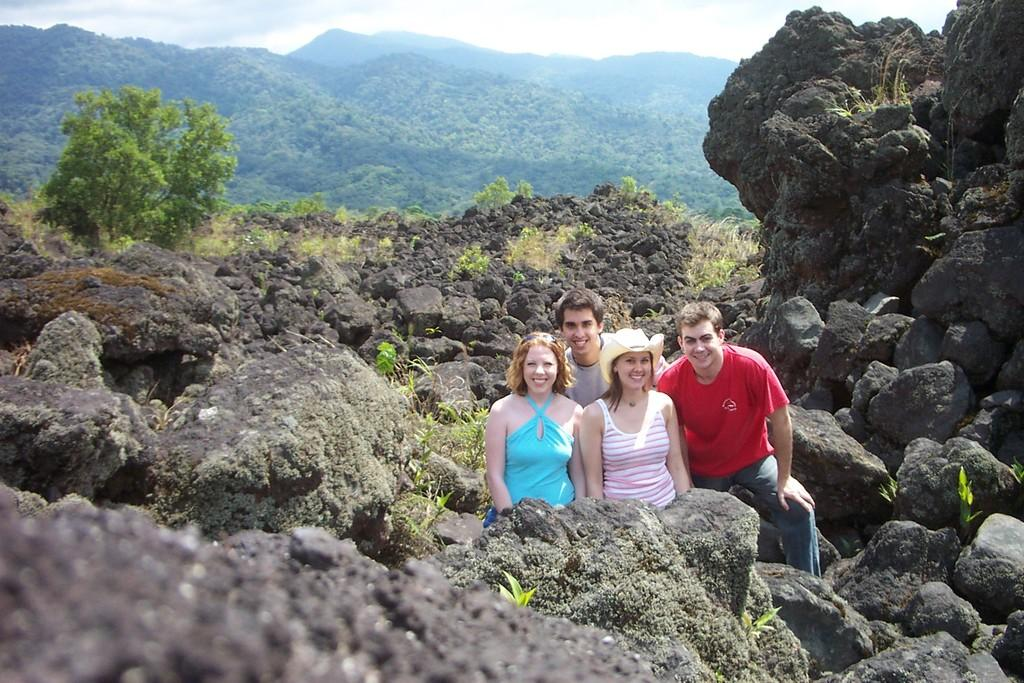Who is present in the image? There are people in the image. What is the facial expression of the people in the image? The people are smiling. Can you describe the attire of one of the individuals in the image? There is a woman wearing a hat. What type of natural elements can be seen in the image? There are stones and trees visible in the image. What is visible in the background of the image? The sky is visible in the background of the image. What type of kettle is visible in the image? There is no kettle present in the image. 